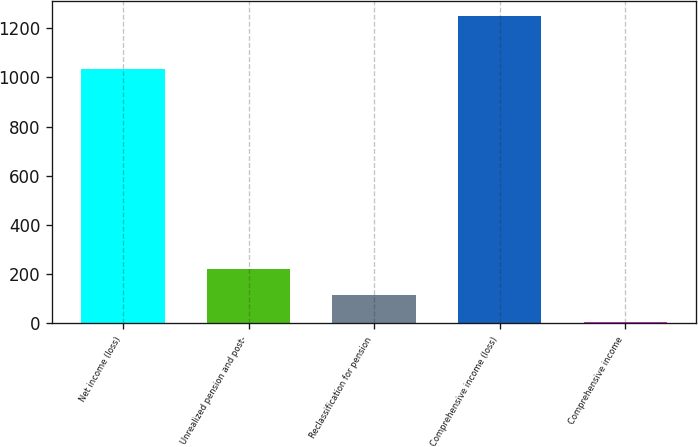Convert chart. <chart><loc_0><loc_0><loc_500><loc_500><bar_chart><fcel>Net income (loss)<fcel>Unrealized pension and post-<fcel>Reclassification for pension<fcel>Comprehensive income (loss)<fcel>Comprehensive income<nl><fcel>1033.6<fcel>222.46<fcel>115.13<fcel>1248.26<fcel>7.8<nl></chart> 